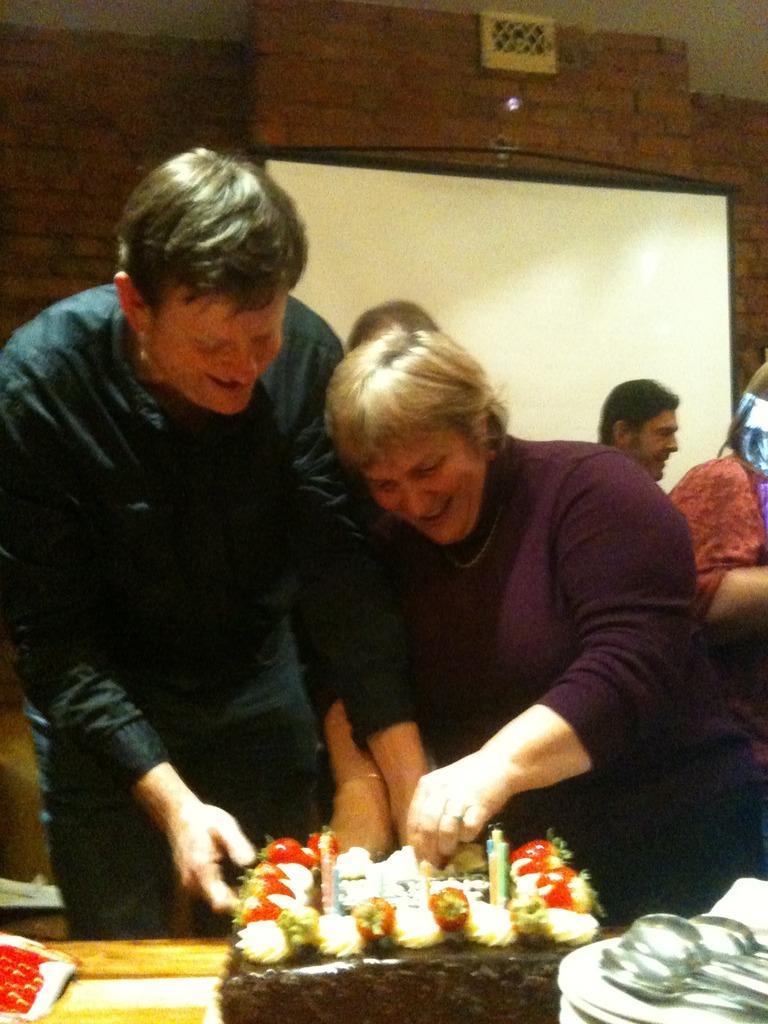Can you describe this image briefly? There are two persons standing in front of a table. On the table there is a cake with some decorations. In the background there are some people also there is a wall with a white board. On the right corner there are many plates and on that there are many spoons. 